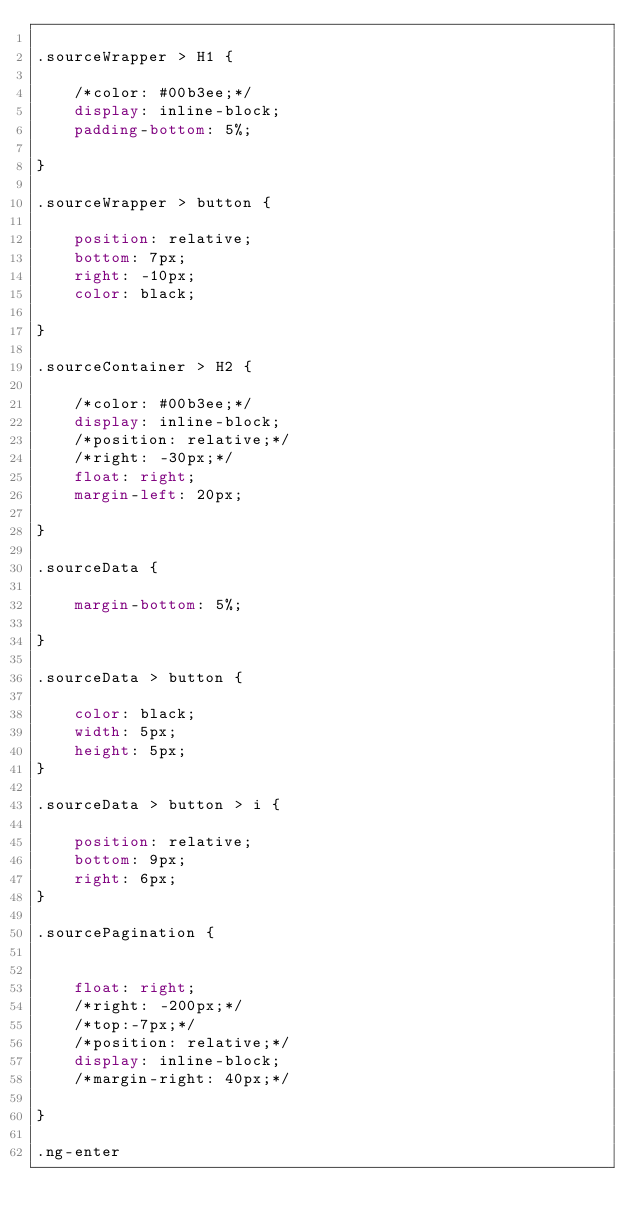<code> <loc_0><loc_0><loc_500><loc_500><_CSS_>
.sourceWrapper > H1 {

    /*color: #00b3ee;*/
    display: inline-block;
    padding-bottom: 5%;

}

.sourceWrapper > button {

    position: relative;
    bottom: 7px;
    right: -10px;
    color: black;

}

.sourceContainer > H2 {

    /*color: #00b3ee;*/
    display: inline-block;
    /*position: relative;*/
    /*right: -30px;*/
    float: right;
    margin-left: 20px;

}

.sourceData {

    margin-bottom: 5%;

}

.sourceData > button {

    color: black;
    width: 5px;
    height: 5px;
}

.sourceData > button > i {

    position: relative;
    bottom: 9px;
    right: 6px;
}

.sourcePagination {


    float: right;
    /*right: -200px;*/
    /*top:-7px;*/
    /*position: relative;*/
    display: inline-block;
    /*margin-right: 40px;*/

}

.ng-enter</code> 